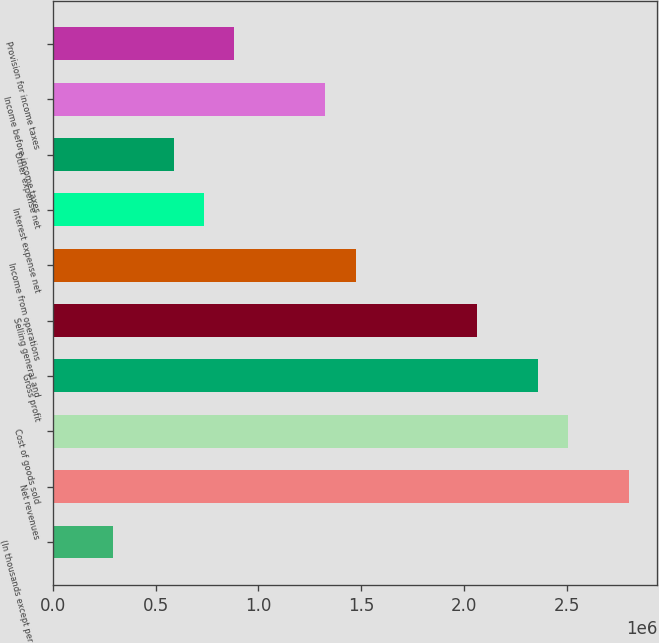Convert chart to OTSL. <chart><loc_0><loc_0><loc_500><loc_500><bar_chart><fcel>(In thousands except per share<fcel>Net revenues<fcel>Cost of goods sold<fcel>Gross profit<fcel>Selling general and<fcel>Income from operations<fcel>Interest expense net<fcel>Other expense net<fcel>Income before income taxes<fcel>Provision for income taxes<nl><fcel>294537<fcel>2.7981e+06<fcel>2.50356e+06<fcel>2.35629e+06<fcel>2.06176e+06<fcel>1.47268e+06<fcel>736342<fcel>589074<fcel>1.32542e+06<fcel>883611<nl></chart> 